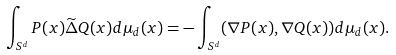<formula> <loc_0><loc_0><loc_500><loc_500>\int _ { S ^ { d } } P ( x ) \widetilde { \Delta } Q ( x ) d \mu _ { d } ( x ) = - \int _ { S ^ { d } } ( \nabla P ( x ) , \nabla Q ( x ) ) d \mu _ { d } ( x ) .</formula> 